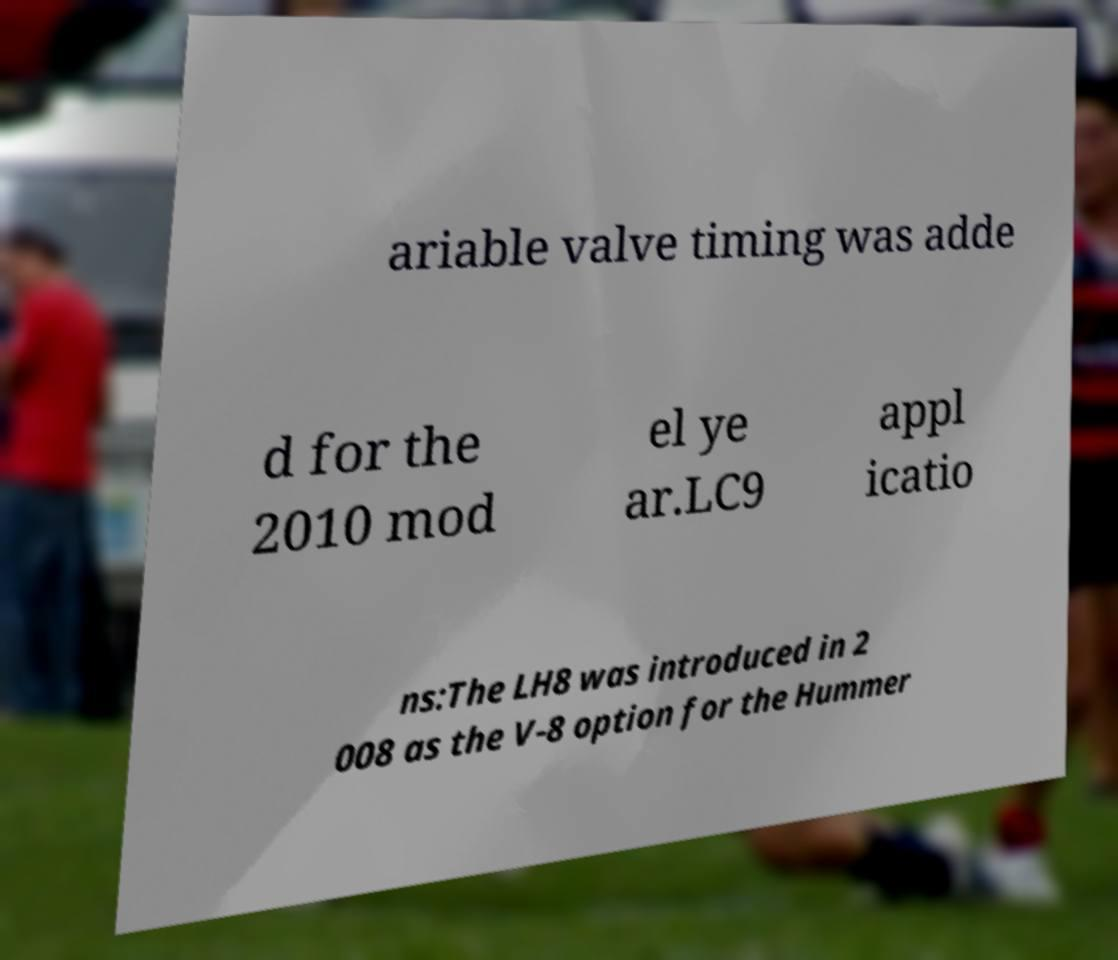I need the written content from this picture converted into text. Can you do that? ariable valve timing was adde d for the 2010 mod el ye ar.LC9 appl icatio ns:The LH8 was introduced in 2 008 as the V-8 option for the Hummer 